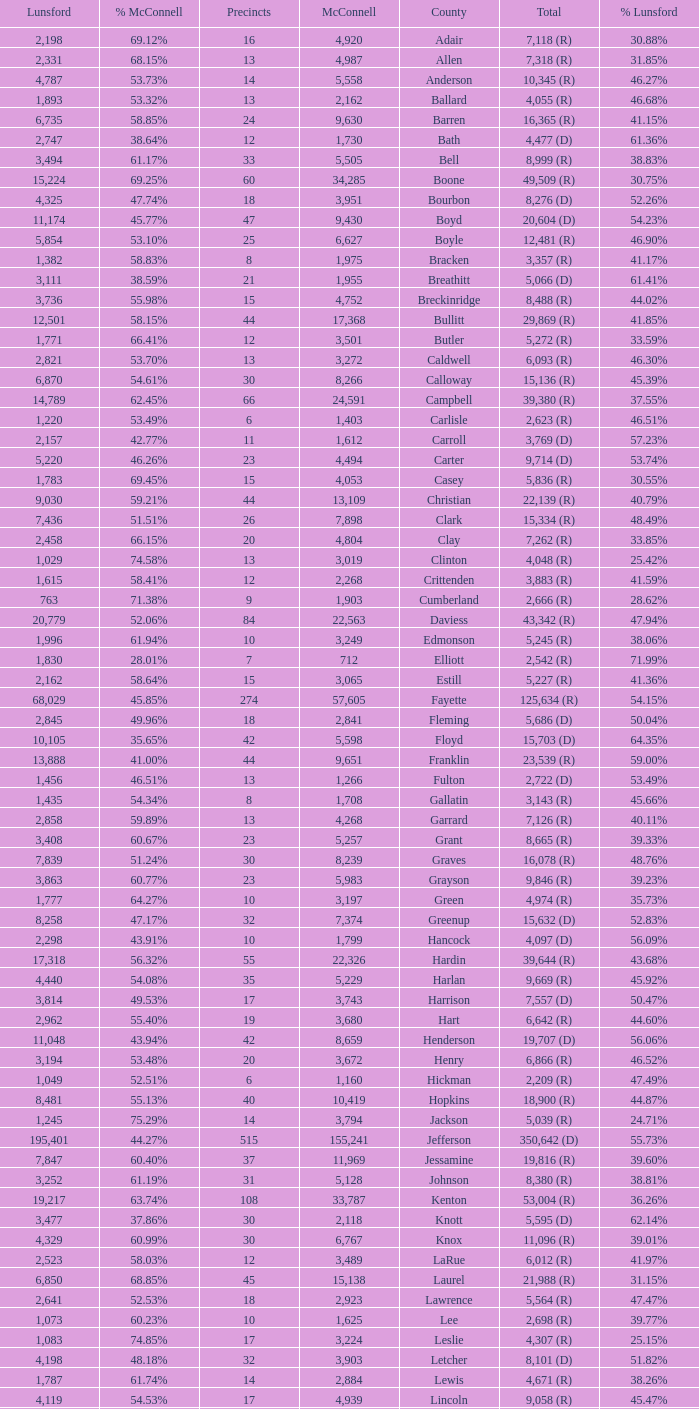What is the total number of Lunsford votes when the percentage of those votes is 33.85%? 1.0. 